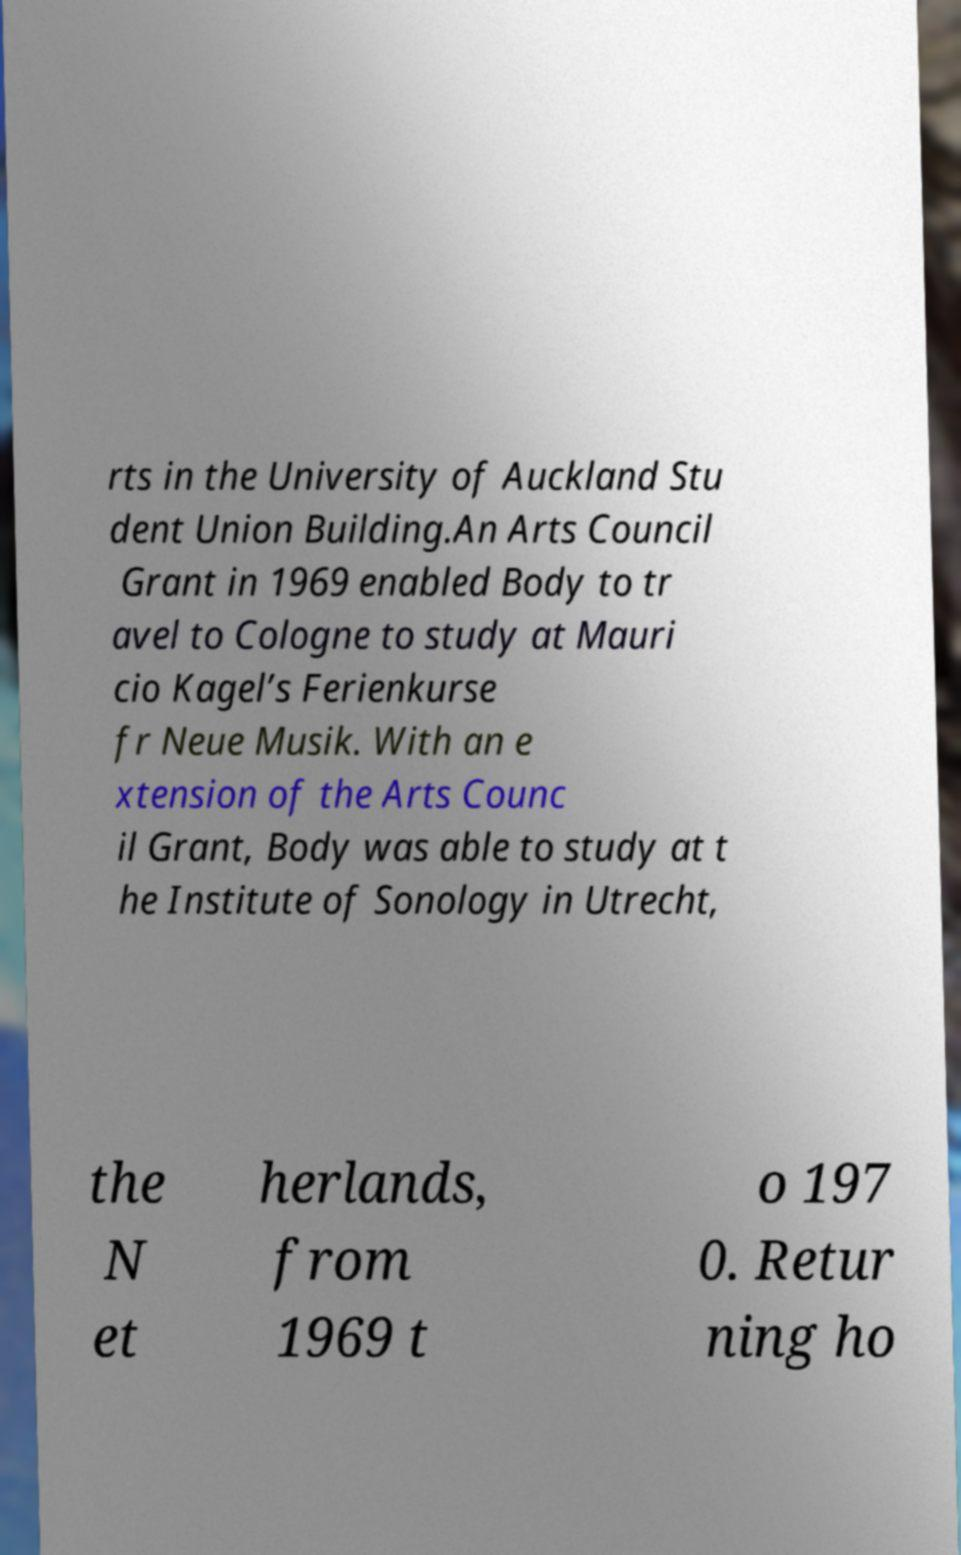There's text embedded in this image that I need extracted. Can you transcribe it verbatim? rts in the University of Auckland Stu dent Union Building.An Arts Council Grant in 1969 enabled Body to tr avel to Cologne to study at Mauri cio Kagel’s Ferienkurse fr Neue Musik. With an e xtension of the Arts Counc il Grant, Body was able to study at t he Institute of Sonology in Utrecht, the N et herlands, from 1969 t o 197 0. Retur ning ho 